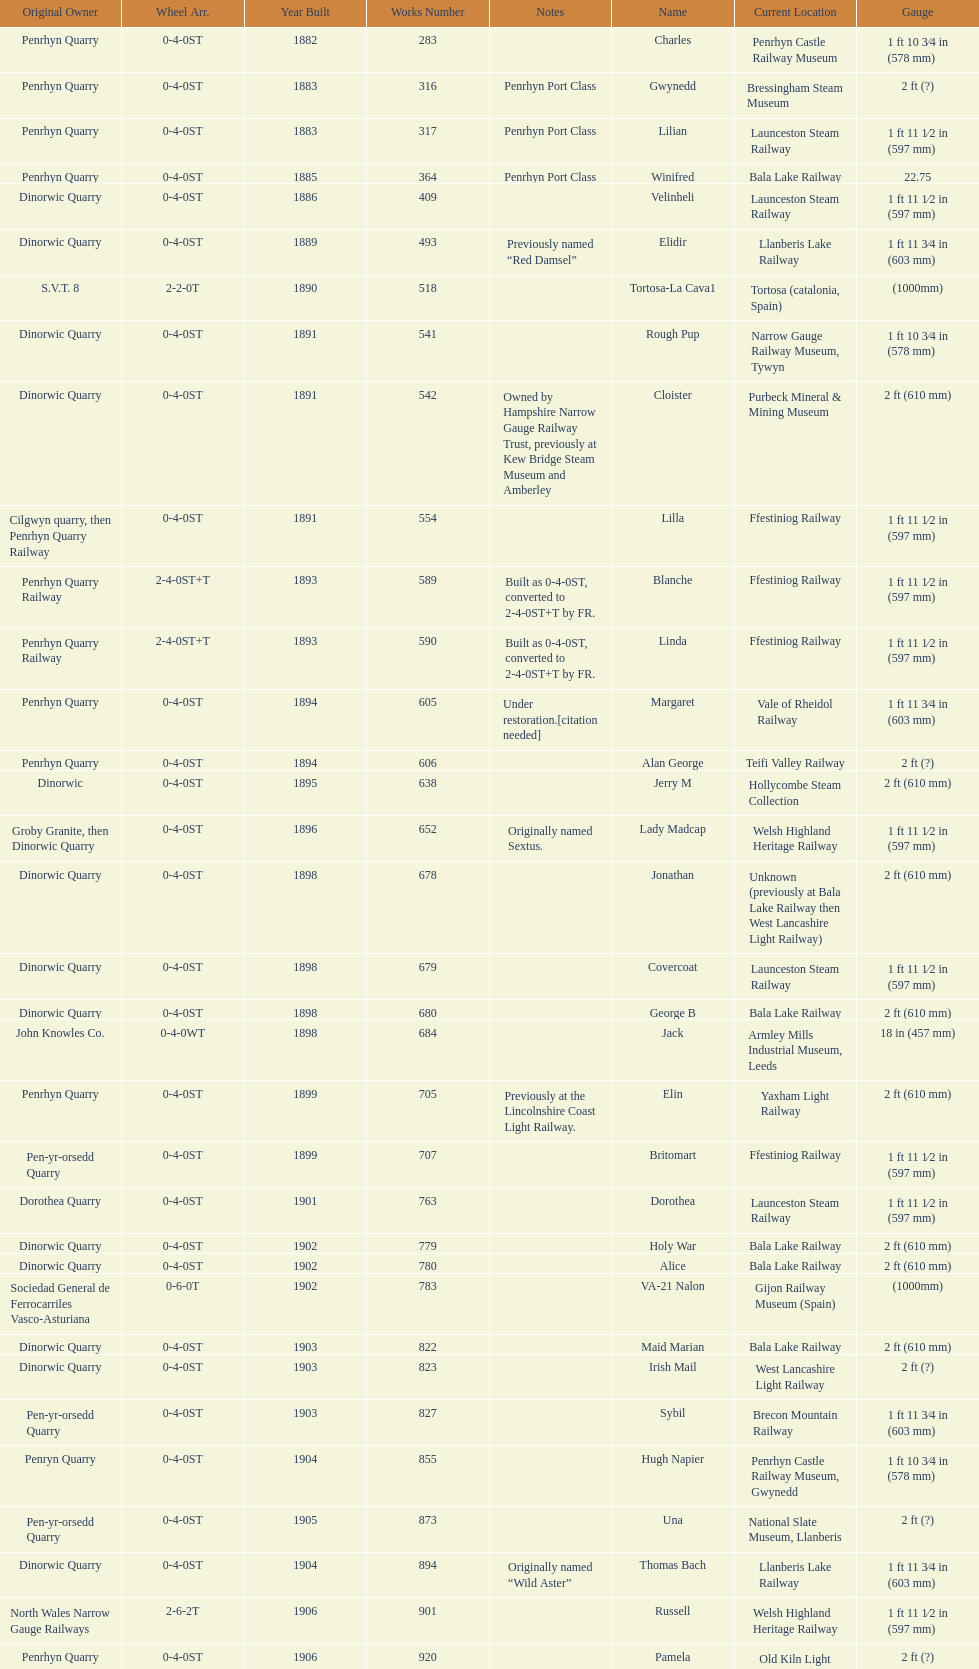What is the difference in gauge between works numbers 541 and 542? 32 mm. 